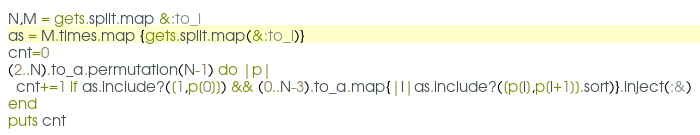<code> <loc_0><loc_0><loc_500><loc_500><_Ruby_>N,M = gets.split.map &:to_i
as = M.times.map {gets.split.map(&:to_i)}
cnt=0
(2..N).to_a.permutation(N-1) do |p|
  cnt+=1 if as.include?([1,p[0]]) && (0..N-3).to_a.map{|i|as.include?([p[i],p[i+1]].sort)}.inject(:&)
end
puts cnt
</code> 